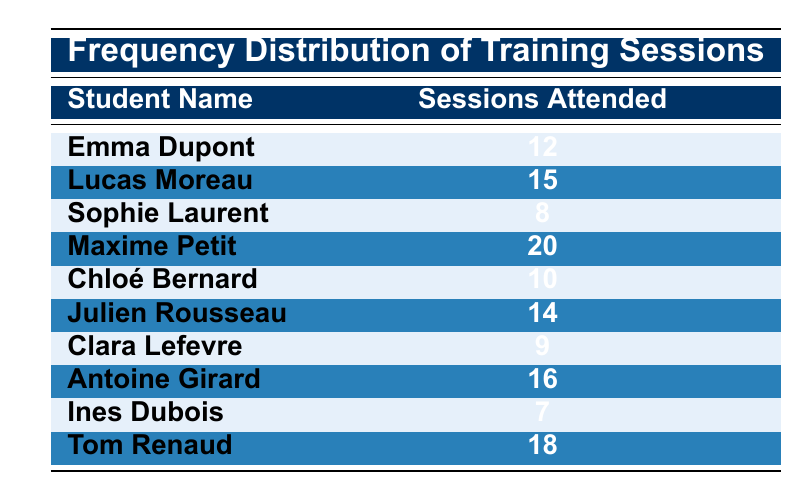What is the maximum number of training sessions attended by a student? By looking at the "Sessions Attended" column, the highest value listed is 20 for Maxime Petit.
Answer: 20 Who attended more training sessions, Sophie Laurent or Clara Lefevre? Sophie Laurent attended 8 sessions, while Clara Lefevre attended 9 sessions. Since 9 is greater than 8, Clara Lefevre attended more sessions.
Answer: Clara Lefevre What is the average number of training sessions attended by all students? To find the average, sum all the sessions attended: 12 + 15 + 8 + 20 + 10 + 14 + 9 + 16 + 7 + 18 = 129. There are 10 students, so the average is 129 / 10 = 12.9.
Answer: 12.9 Is there any student who attended exactly 15 training sessions? Yes, according to the table, Lucas Moreau attended 15 training sessions.
Answer: Yes How many students attended more than 10 training sessions? The students who attended more than 10 sessions are Lucas Moreau, Maxime Petit, Julien Rousseau, Antoine Girard, and Tom Renaud. Counting these names gives us 5 students.
Answer: 5 What is the difference between the highest and lowest number of training sessions attended? The highest is 20 (Maxime Petit) and the lowest is 7 (Ines Dubois). The difference is 20 - 7 = 13.
Answer: 13 Did any student attend fewer than 8 training sessions? Yes, Ines Dubois attended 7 training sessions, which is fewer than 8.
Answer: Yes How many students attended an even number of training sessions? The even numbers in the "Sessions Attended" column are 12, 10, 14, 16, and 18. Counting these gives us 5 students who attended even numbers of sessions.
Answer: 5 Which student's attendance is in the middle when all attendances are arranged in ascending order? The attendance numbers in ascending order are 7, 8, 9, 10, 12, 14, 15, 16, 18, 20. The middle values (5th and 6th) are 12 and 14, with the average being (12 + 14) / 2 = 13.
Answer: 13 